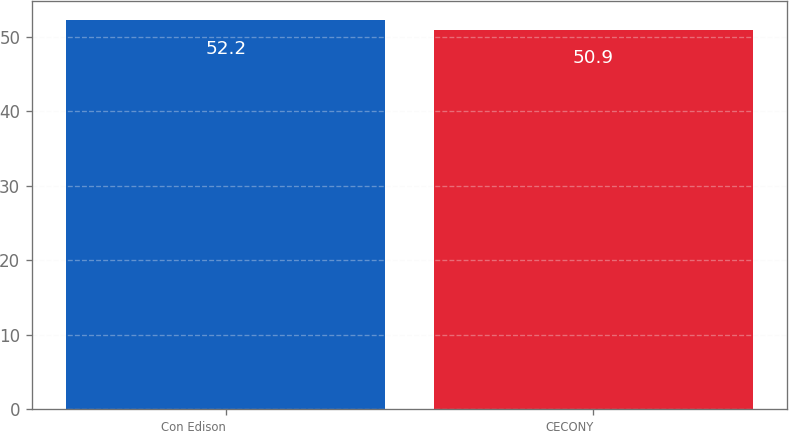<chart> <loc_0><loc_0><loc_500><loc_500><bar_chart><fcel>Con Edison<fcel>CECONY<nl><fcel>52.2<fcel>50.9<nl></chart> 